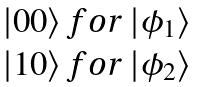Convert formula to latex. <formula><loc_0><loc_0><loc_500><loc_500>\begin{matrix} | 0 0 \rangle \, f o r \, | \phi _ { 1 } \rangle \\ | 1 0 \rangle \, f o r \, | \phi _ { 2 } \rangle \end{matrix}</formula> 